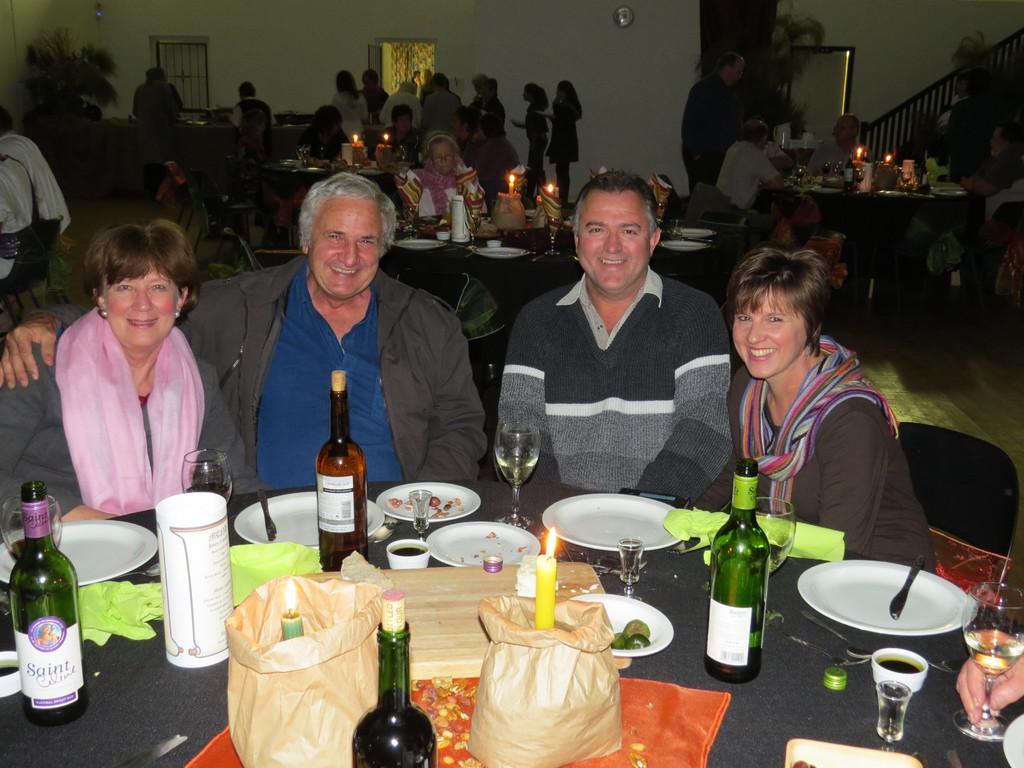How would you summarize this image in a sentence or two? There are four people sitting on the chairs. In front of them there is a table. On the table there are bottles, glasses, plates, candles, covers and many other items. In the background there are many tables, candles and many other items. Also there is a wall with window, door and a clock. Also there is a staircase. 